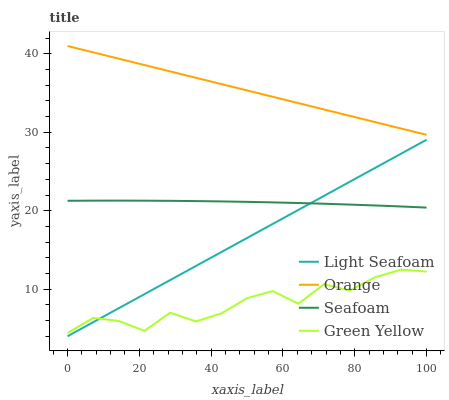Does Light Seafoam have the minimum area under the curve?
Answer yes or no. No. Does Light Seafoam have the maximum area under the curve?
Answer yes or no. No. Is Green Yellow the smoothest?
Answer yes or no. No. Is Light Seafoam the roughest?
Answer yes or no. No. Does Green Yellow have the lowest value?
Answer yes or no. No. Does Light Seafoam have the highest value?
Answer yes or no. No. Is Seafoam less than Orange?
Answer yes or no. Yes. Is Orange greater than Light Seafoam?
Answer yes or no. Yes. Does Seafoam intersect Orange?
Answer yes or no. No. 